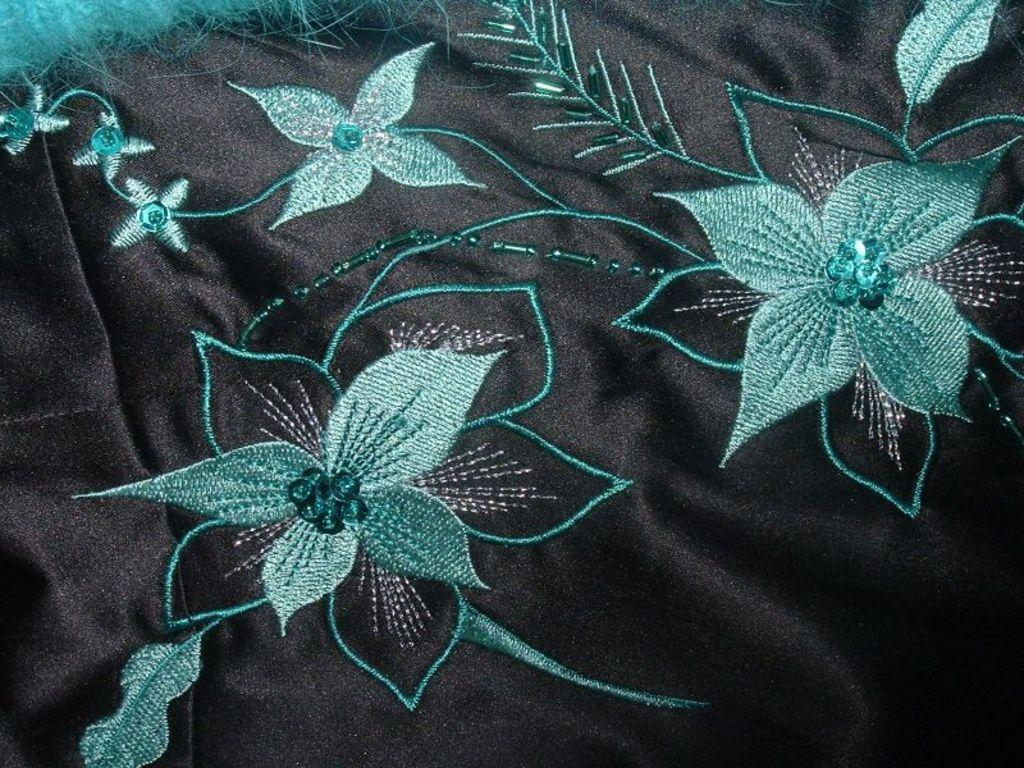What is the main subject in the center of the image? There is a cloth in the center of the image. What type of cabbage is growing in the hole in the cloth? There is no cabbage or hole present in the image; it only features a cloth. 